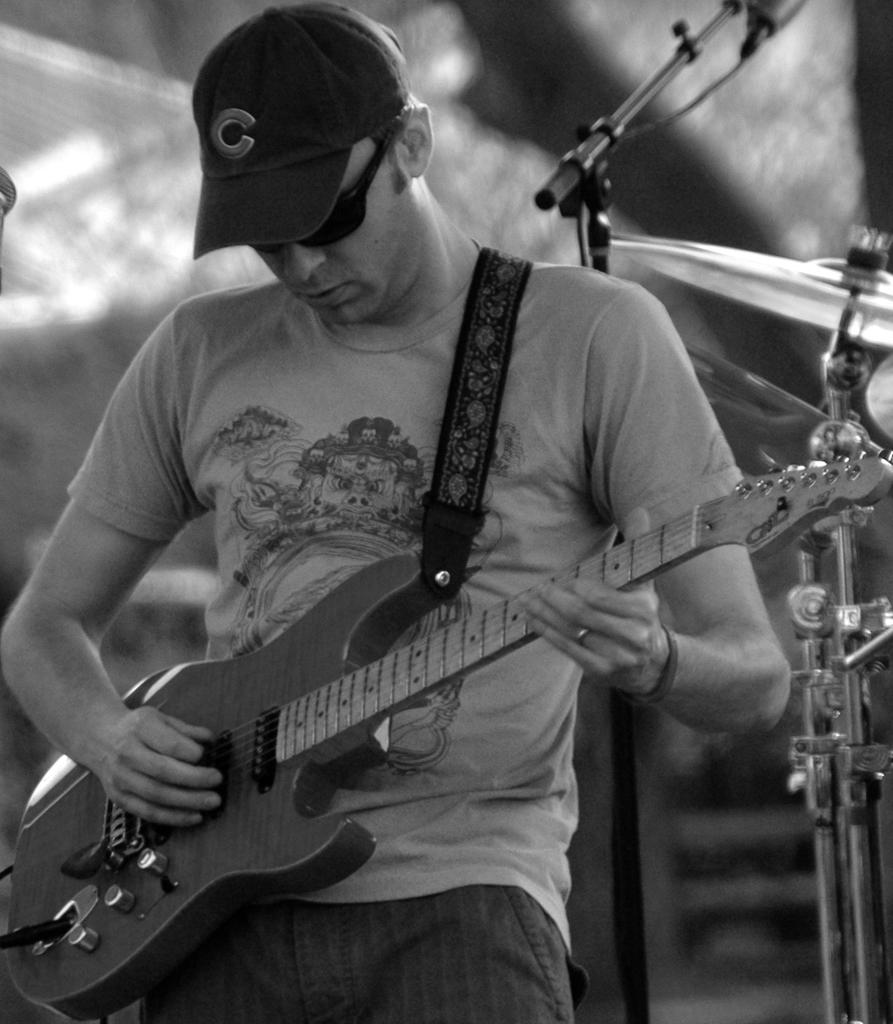What is the man in the image holding? The man is holding a guitar. What is the man doing with the guitar? The man is playing the guitar. Can you describe the man's clothing in the image? The man is wearing a T-shirt, a cap, and glasses. What can be seen in the background of the image? There is a stand and an orchestra in the background of the image. What type of letter is the man writing in the image? There is no letter present in the image; the man is playing the guitar. Where is the bedroom located in the image? There is no bedroom present in the image. 